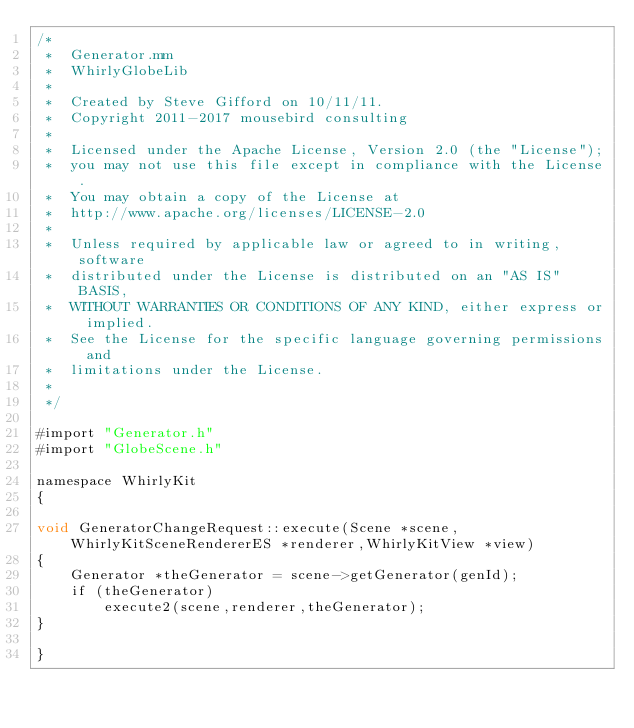<code> <loc_0><loc_0><loc_500><loc_500><_ObjectiveC_>/*
 *  Generator.mm
 *  WhirlyGlobeLib
 *
 *  Created by Steve Gifford on 10/11/11.
 *  Copyright 2011-2017 mousebird consulting
 *
 *  Licensed under the Apache License, Version 2.0 (the "License");
 *  you may not use this file except in compliance with the License.
 *  You may obtain a copy of the License at
 *  http://www.apache.org/licenses/LICENSE-2.0
 *
 *  Unless required by applicable law or agreed to in writing, software
 *  distributed under the License is distributed on an "AS IS" BASIS,
 *  WITHOUT WARRANTIES OR CONDITIONS OF ANY KIND, either express or implied.
 *  See the License for the specific language governing permissions and
 *  limitations under the License.
 *
 */

#import "Generator.h"
#import "GlobeScene.h"

namespace WhirlyKit
{
    
void GeneratorChangeRequest::execute(Scene *scene,WhirlyKitSceneRendererES *renderer,WhirlyKitView *view)
{
    Generator *theGenerator = scene->getGenerator(genId);
	if (theGenerator)
		execute2(scene,renderer,theGenerator);    
}

}
</code> 